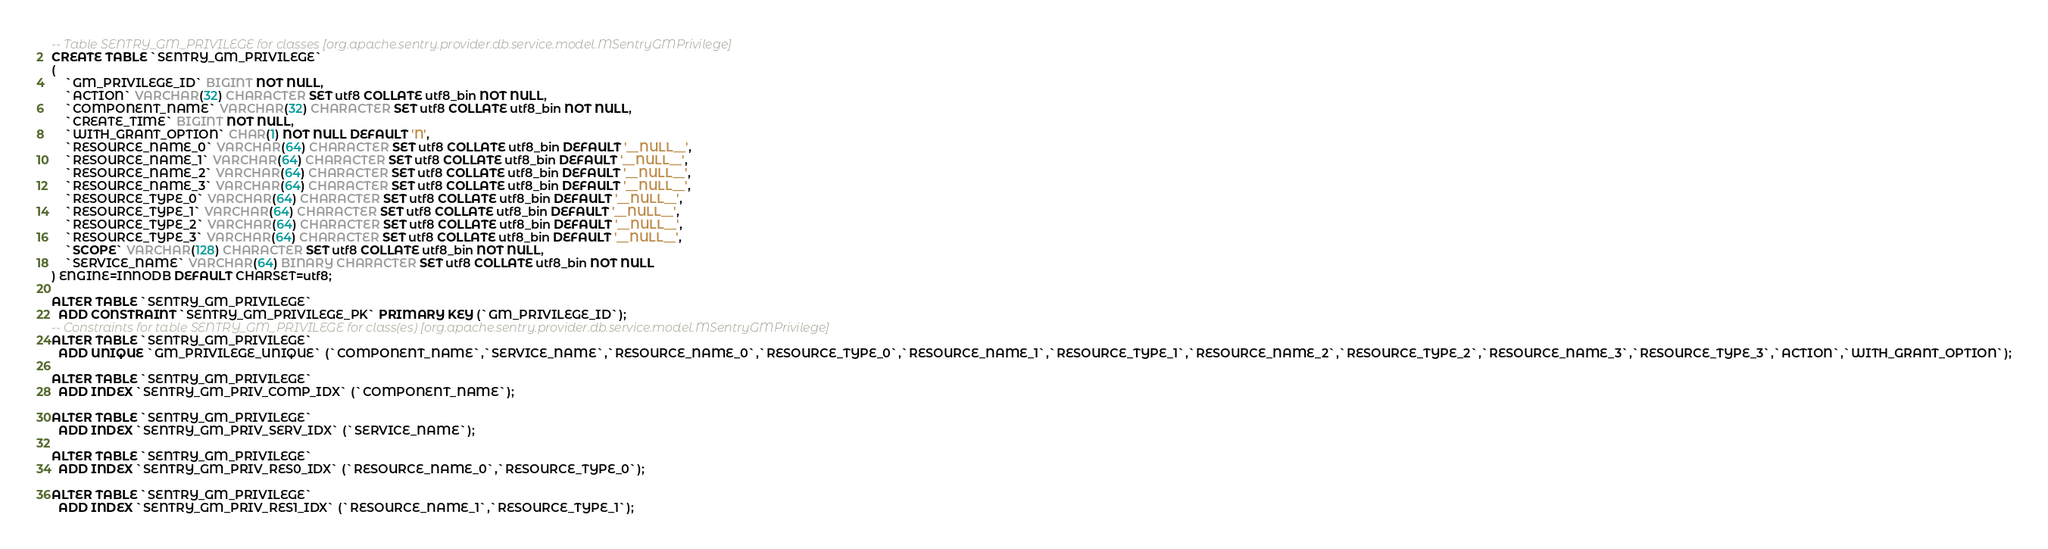Convert code to text. <code><loc_0><loc_0><loc_500><loc_500><_SQL_>-- Table SENTRY_GM_PRIVILEGE for classes [org.apache.sentry.provider.db.service.model.MSentryGMPrivilege]
CREATE TABLE `SENTRY_GM_PRIVILEGE`
(
    `GM_PRIVILEGE_ID` BIGINT NOT NULL,
    `ACTION` VARCHAR(32) CHARACTER SET utf8 COLLATE utf8_bin NOT NULL,
    `COMPONENT_NAME` VARCHAR(32) CHARACTER SET utf8 COLLATE utf8_bin NOT NULL,
    `CREATE_TIME` BIGINT NOT NULL,
    `WITH_GRANT_OPTION` CHAR(1) NOT NULL DEFAULT 'N',
    `RESOURCE_NAME_0` VARCHAR(64) CHARACTER SET utf8 COLLATE utf8_bin DEFAULT '__NULL__',
    `RESOURCE_NAME_1` VARCHAR(64) CHARACTER SET utf8 COLLATE utf8_bin DEFAULT '__NULL__',
    `RESOURCE_NAME_2` VARCHAR(64) CHARACTER SET utf8 COLLATE utf8_bin DEFAULT '__NULL__',
    `RESOURCE_NAME_3` VARCHAR(64) CHARACTER SET utf8 COLLATE utf8_bin DEFAULT '__NULL__',
    `RESOURCE_TYPE_0` VARCHAR(64) CHARACTER SET utf8 COLLATE utf8_bin DEFAULT '__NULL__',
    `RESOURCE_TYPE_1` VARCHAR(64) CHARACTER SET utf8 COLLATE utf8_bin DEFAULT '__NULL__',
    `RESOURCE_TYPE_2` VARCHAR(64) CHARACTER SET utf8 COLLATE utf8_bin DEFAULT '__NULL__',
    `RESOURCE_TYPE_3` VARCHAR(64) CHARACTER SET utf8 COLLATE utf8_bin DEFAULT '__NULL__',
    `SCOPE` VARCHAR(128) CHARACTER SET utf8 COLLATE utf8_bin NOT NULL,
    `SERVICE_NAME` VARCHAR(64) BINARY CHARACTER SET utf8 COLLATE utf8_bin NOT NULL
) ENGINE=INNODB DEFAULT CHARSET=utf8;

ALTER TABLE `SENTRY_GM_PRIVILEGE`
  ADD CONSTRAINT `SENTRY_GM_PRIVILEGE_PK` PRIMARY KEY (`GM_PRIVILEGE_ID`);
-- Constraints for table SENTRY_GM_PRIVILEGE for class(es) [org.apache.sentry.provider.db.service.model.MSentryGMPrivilege]
ALTER TABLE `SENTRY_GM_PRIVILEGE`
  ADD UNIQUE `GM_PRIVILEGE_UNIQUE` (`COMPONENT_NAME`,`SERVICE_NAME`,`RESOURCE_NAME_0`,`RESOURCE_TYPE_0`,`RESOURCE_NAME_1`,`RESOURCE_TYPE_1`,`RESOURCE_NAME_2`,`RESOURCE_TYPE_2`,`RESOURCE_NAME_3`,`RESOURCE_TYPE_3`,`ACTION`,`WITH_GRANT_OPTION`);

ALTER TABLE `SENTRY_GM_PRIVILEGE`
  ADD INDEX `SENTRY_GM_PRIV_COMP_IDX` (`COMPONENT_NAME`);

ALTER TABLE `SENTRY_GM_PRIVILEGE`
  ADD INDEX `SENTRY_GM_PRIV_SERV_IDX` (`SERVICE_NAME`);

ALTER TABLE `SENTRY_GM_PRIVILEGE`
  ADD INDEX `SENTRY_GM_PRIV_RES0_IDX` (`RESOURCE_NAME_0`,`RESOURCE_TYPE_0`);

ALTER TABLE `SENTRY_GM_PRIVILEGE`
  ADD INDEX `SENTRY_GM_PRIV_RES1_IDX` (`RESOURCE_NAME_1`,`RESOURCE_TYPE_1`);
</code> 